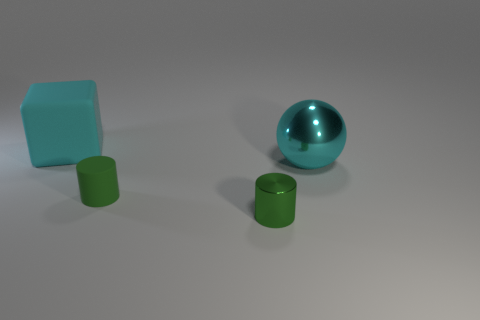Is there another rubber block of the same size as the cyan matte block?
Offer a terse response. No. Is the number of big cyan cylinders greater than the number of cubes?
Your answer should be compact. No. Is the size of the cyan thing that is left of the big sphere the same as the cyan object in front of the cyan block?
Give a very brief answer. Yes. How many things are in front of the large cyan block and left of the cyan ball?
Give a very brief answer. 2. What is the color of the other small thing that is the same shape as the green matte thing?
Your answer should be very brief. Green. Is the number of large metallic objects less than the number of cyan metallic blocks?
Your response must be concise. No. Do the cyan cube and the cylinder on the right side of the matte cylinder have the same size?
Your answer should be compact. No. What color is the rubber object behind the large cyan shiny thing that is to the right of the large rubber block?
Make the answer very short. Cyan. What number of things are things to the left of the big cyan shiny ball or things that are in front of the big cyan matte cube?
Keep it short and to the point. 4. Does the cyan rubber thing have the same size as the green matte thing?
Your answer should be compact. No. 